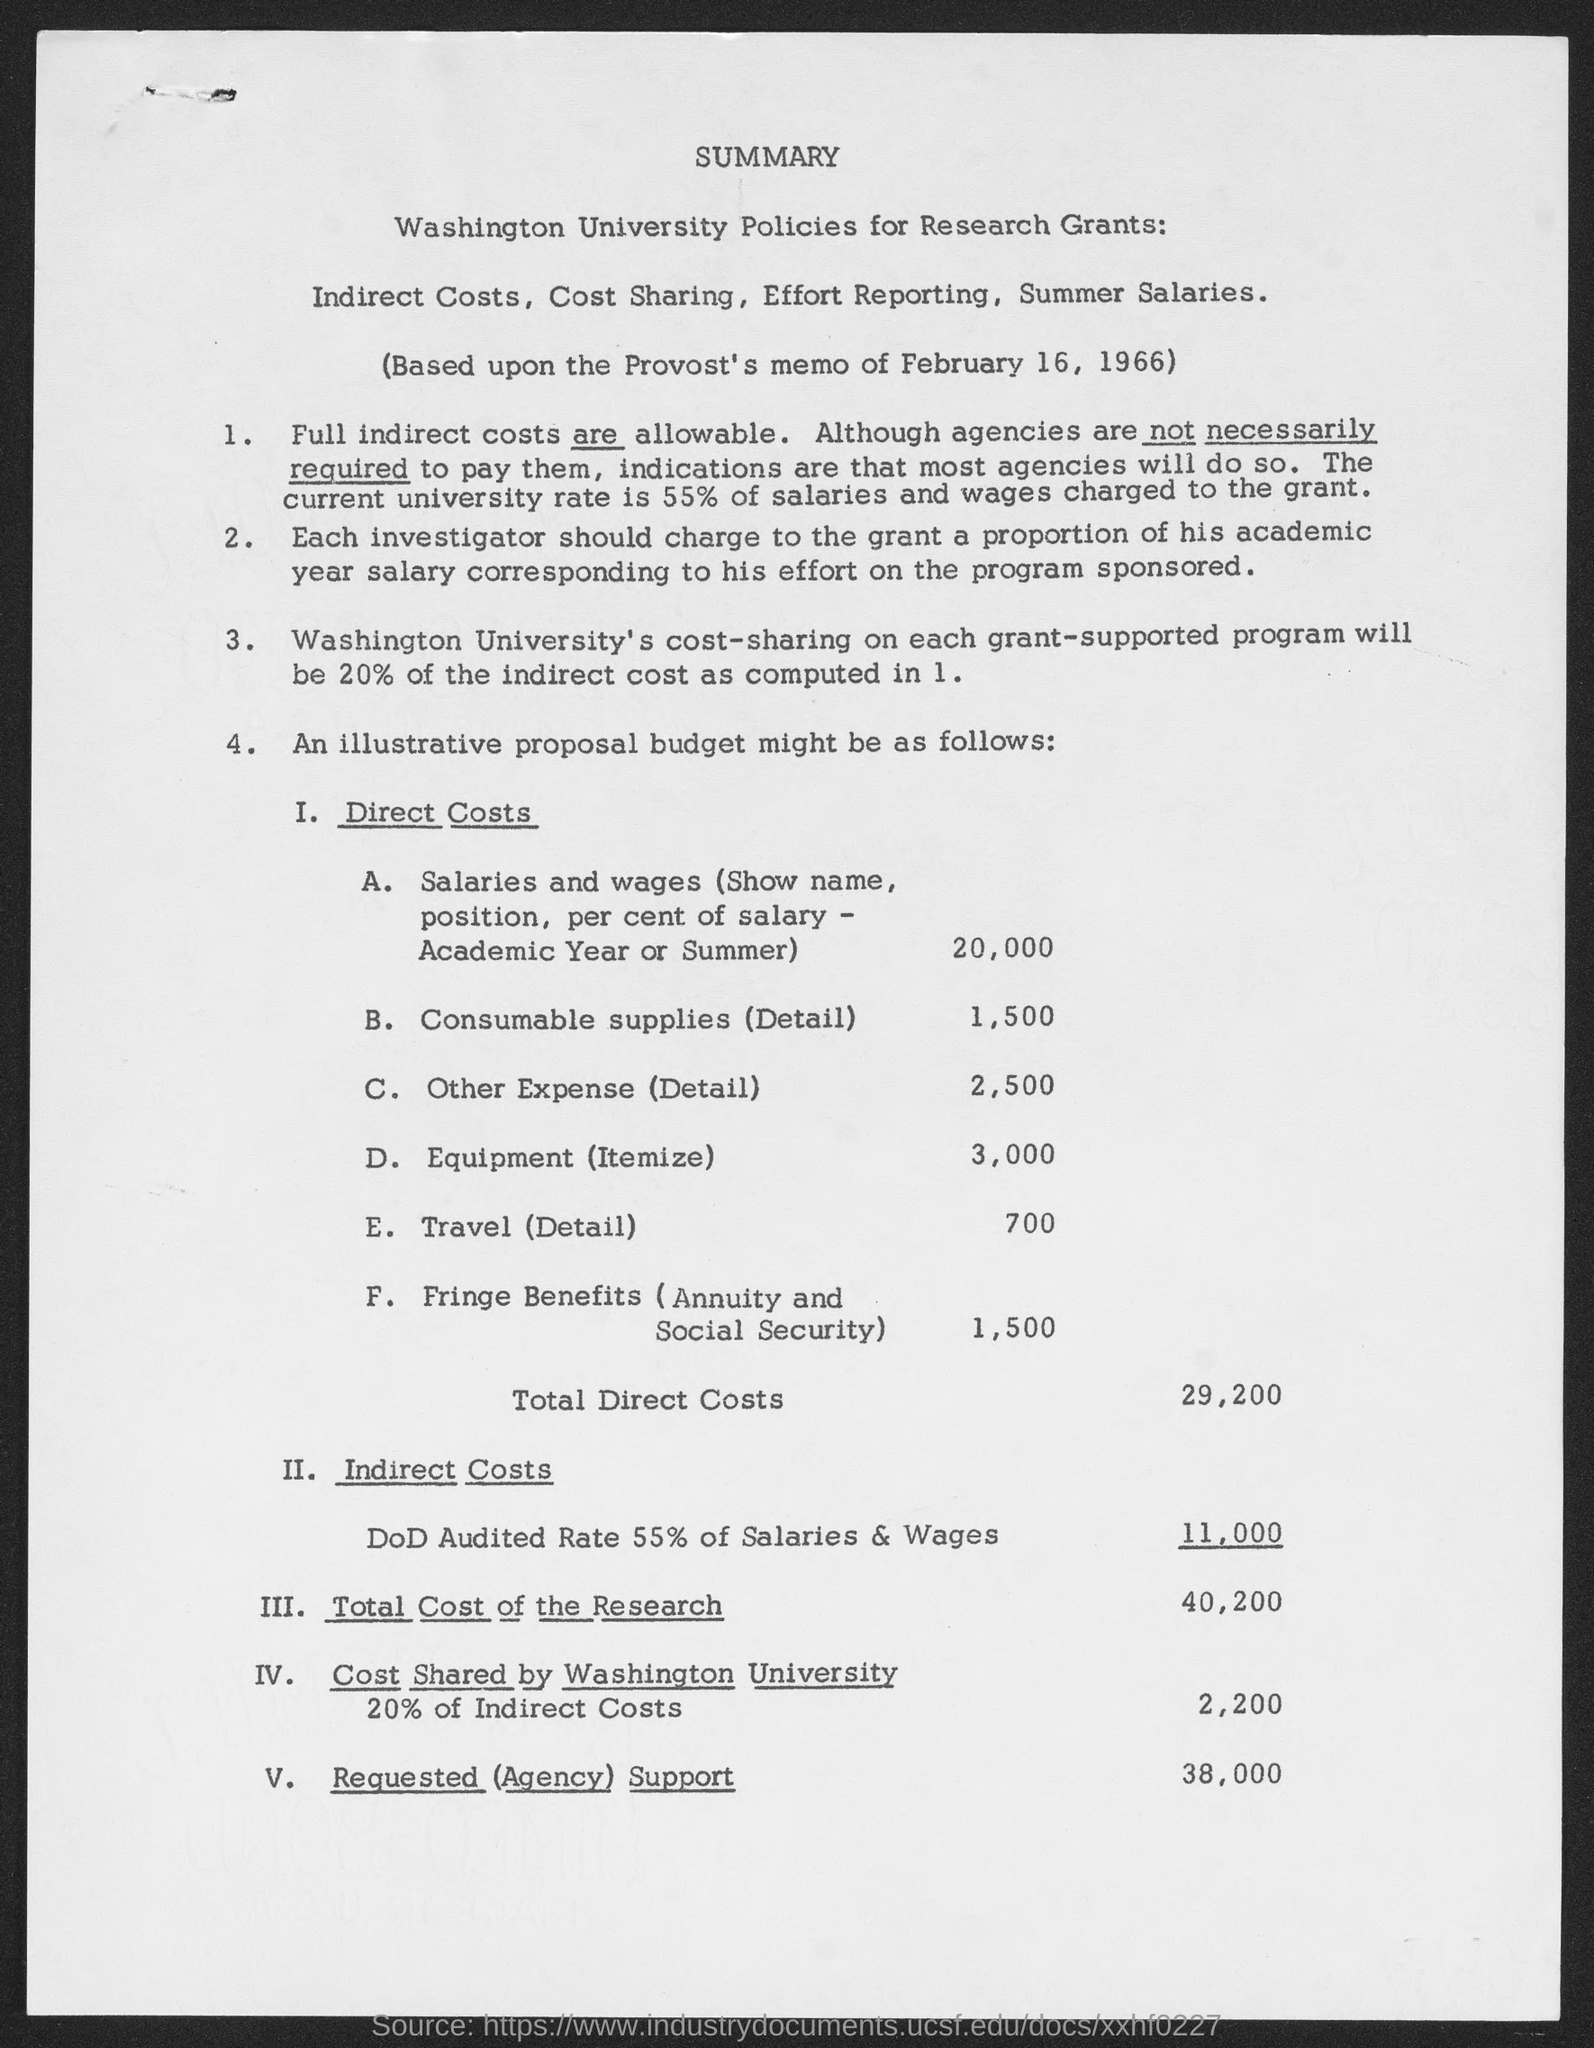What is the total cost of the research ?
Your response must be concise. 40,200. What is the total direct costs ?
Your response must be concise. $29,200. What is the requested (agency) support?
Keep it short and to the point. 38,000. 